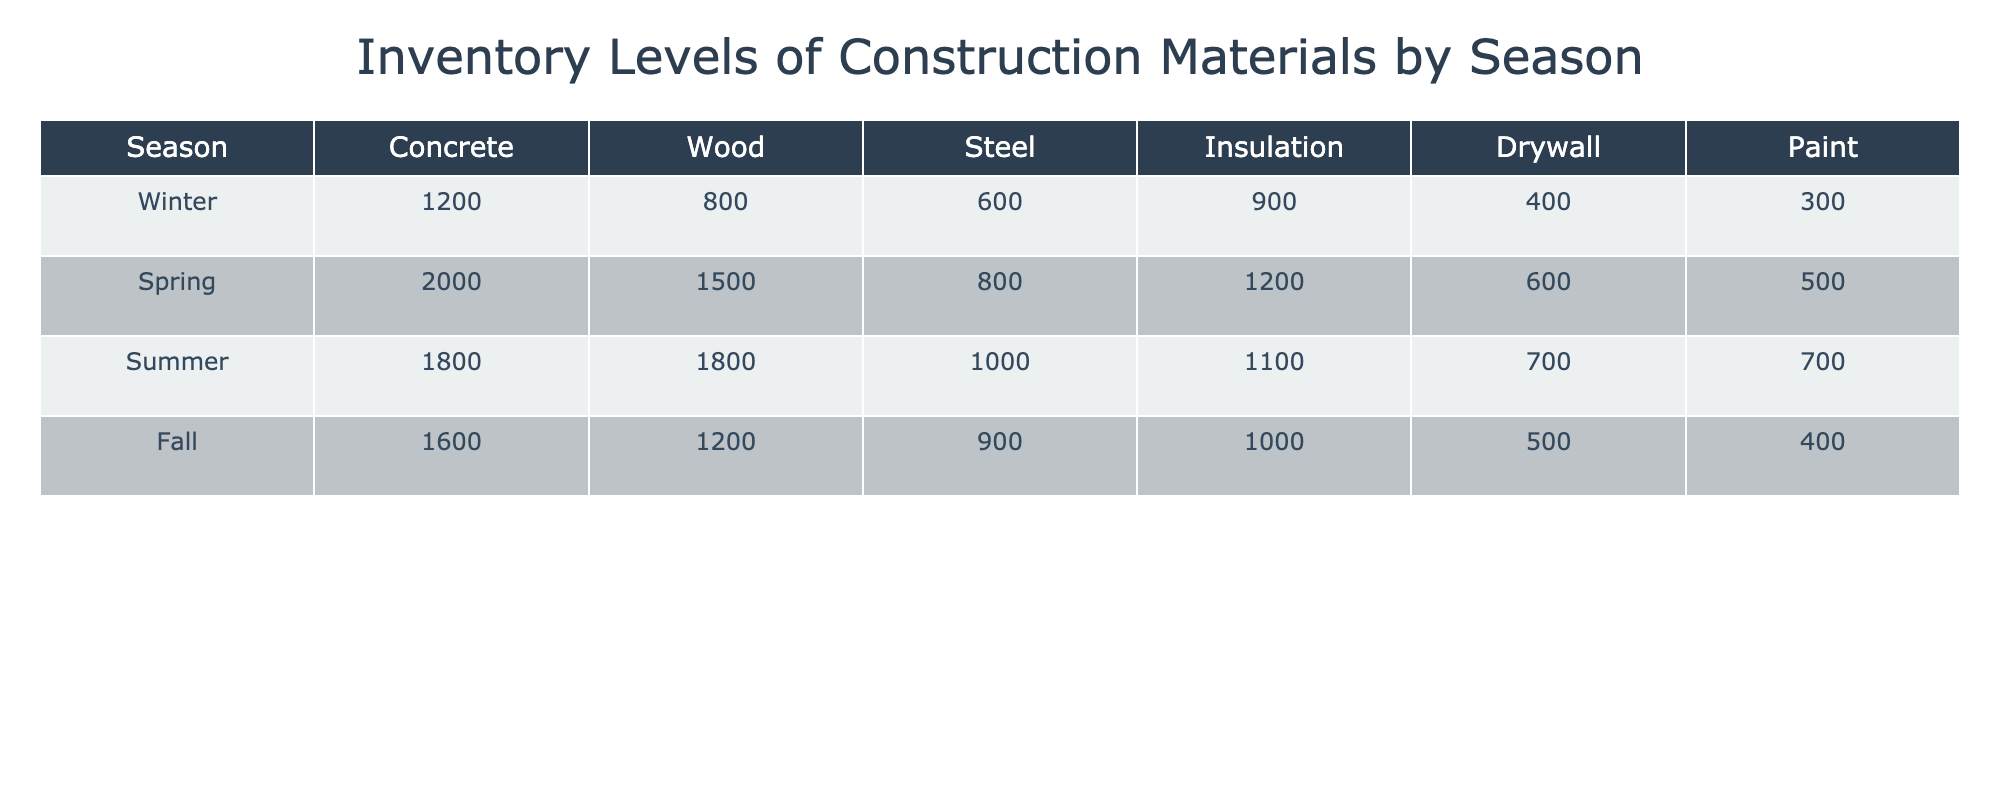What is the inventory level of Paint in Spring? In the table, under the Spring row, the value corresponding to Paint is found. It indicates the amount of Paint available during that season.
Answer: 500 Which season has the highest inventory level of Steel? The Steel column in the table shows the inventory levels for each season. By comparing the values, we can determine which season, Winter (600), Spring (800), Summer (1000), or Fall (900), has the highest level, which is Summer at 1000.
Answer: Summer What is the total inventory level of Wood across all seasons? To find the total, we sum the values from the Wood column for each season: 800 (Winter) + 1500 (Spring) + 1800 (Summer) + 1200 (Fall) = 4300.
Answer: 4300 Is the inventory level of Insulation higher in Summer than in Winter? Checking the Insulation values shows that in Summer, the inventory is 1100 and in Winter, it is 900. Since 1100 is greater than 900, we conclude that it is indeed higher.
Answer: Yes What is the average inventory level of Concrete in the given seasons? To find the average, we sum the Concrete values: 1200 (Winter) + 2000 (Spring) + 1800 (Summer) + 1600 (Fall) = 6800. Then, we divide by the number of seasons, which is 4: 6800 / 4 = 1700.
Answer: 1700 Which season has the lowest inventory of Drywall, and what is that level? By examining the Drywall column, the values are Winter (400), Spring (600), Summer (700), and Fall (500). The lowest level is found in Winter at 400.
Answer: Winter, 400 What is the difference in inventory levels of Concrete between Spring and Fall? The Concrete inventory for Spring is 2000 and for Fall is 1600. To find the difference, we subtract the Fall value from the Spring value: 2000 - 1600 = 400.
Answer: 400 Are there more inventory levels of Insulation in Summer than in Fall? In Summer, the Insulation level is 1100, while in Fall, it is 1000. Comparing these figures shows that 1100 is greater than 1000, indicating there are more in Summer.
Answer: Yes What is the total inventory across all materials in Winter? We sum the inventory levels from each material in Winter: Concrete (1200) + Wood (800) + Steel (600) + Insulation (900) + Drywall (400) + Paint (300) = 4200.
Answer: 4200 